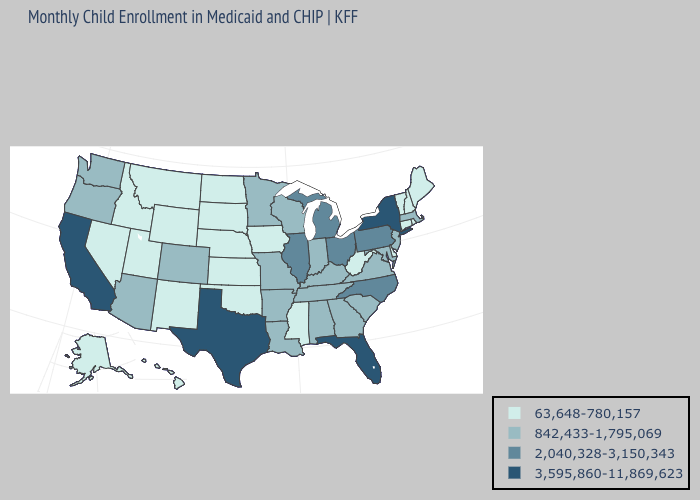What is the highest value in the MidWest ?
Give a very brief answer. 2,040,328-3,150,343. Does Connecticut have a lower value than Pennsylvania?
Answer briefly. Yes. Name the states that have a value in the range 2,040,328-3,150,343?
Short answer required. Illinois, Michigan, North Carolina, Ohio, Pennsylvania. Does Oklahoma have the lowest value in the South?
Keep it brief. Yes. Does Illinois have a lower value than West Virginia?
Concise answer only. No. Does Florida have the same value as Kentucky?
Answer briefly. No. What is the lowest value in the USA?
Keep it brief. 63,648-780,157. Which states hav the highest value in the West?
Give a very brief answer. California. Does Alabama have a lower value than Nevada?
Write a very short answer. No. What is the value of Missouri?
Be succinct. 842,433-1,795,069. Name the states that have a value in the range 3,595,860-11,869,623?
Be succinct. California, Florida, New York, Texas. Name the states that have a value in the range 63,648-780,157?
Write a very short answer. Alaska, Connecticut, Delaware, Hawaii, Idaho, Iowa, Kansas, Maine, Mississippi, Montana, Nebraska, Nevada, New Hampshire, New Mexico, North Dakota, Oklahoma, Rhode Island, South Dakota, Utah, Vermont, West Virginia, Wyoming. What is the value of Maine?
Concise answer only. 63,648-780,157. 